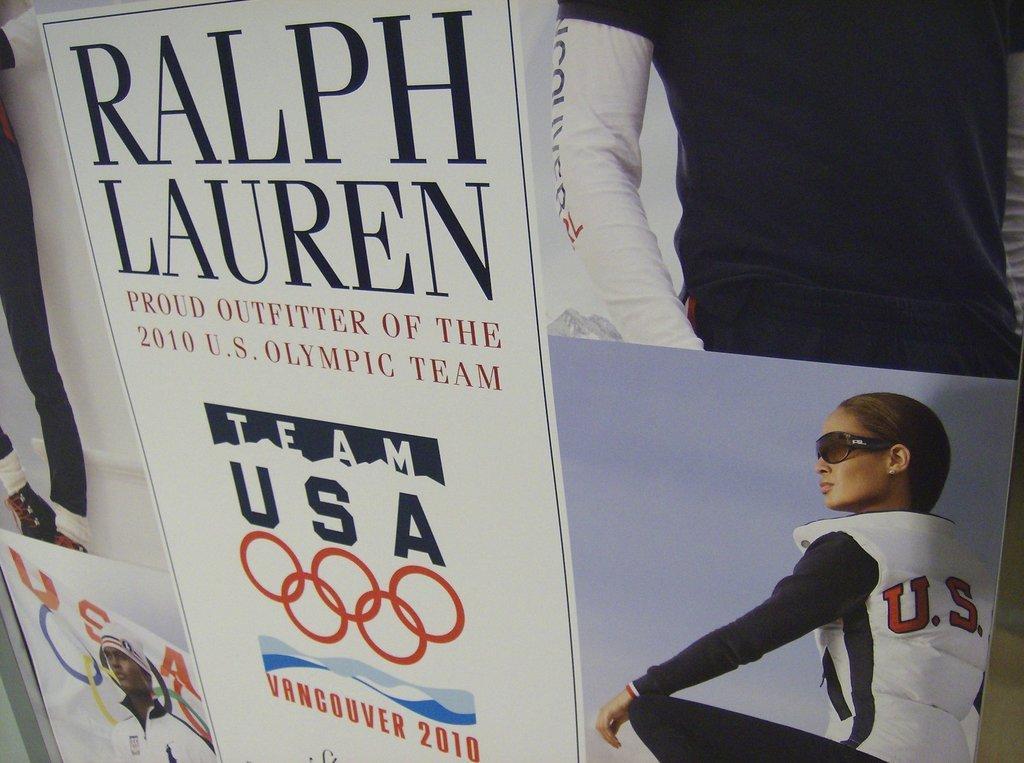Please provide a concise description of this image. In this image I can see a huge banner which is white in color and on the banner I can see a woman wearing black and white colored dress, a person wearing black and white colored dress and few other pictures of persons. 